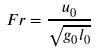<formula> <loc_0><loc_0><loc_500><loc_500>F r = \frac { u _ { 0 } } { \sqrt { g _ { 0 } l _ { 0 } } }</formula> 